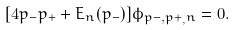Convert formula to latex. <formula><loc_0><loc_0><loc_500><loc_500>[ 4 p _ { - } p _ { + } + E _ { n } ( p _ { - } ) ] \phi _ { p - , p + _ { , } n } = 0 .</formula> 